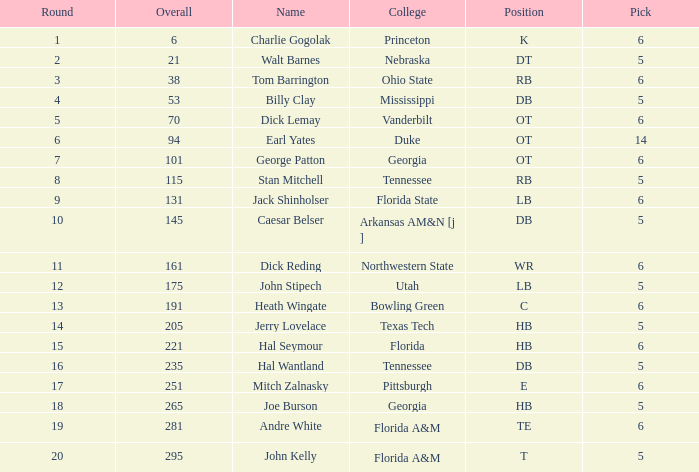What is Name, when Overall is less than 175, and when College is "Georgia"? George Patton. Can you give me this table as a dict? {'header': ['Round', 'Overall', 'Name', 'College', 'Position', 'Pick'], 'rows': [['1', '6', 'Charlie Gogolak', 'Princeton', 'K', '6'], ['2', '21', 'Walt Barnes', 'Nebraska', 'DT', '5'], ['3', '38', 'Tom Barrington', 'Ohio State', 'RB', '6'], ['4', '53', 'Billy Clay', 'Mississippi', 'DB', '5'], ['5', '70', 'Dick Lemay', 'Vanderbilt', 'OT', '6'], ['6', '94', 'Earl Yates', 'Duke', 'OT', '14'], ['7', '101', 'George Patton', 'Georgia', 'OT', '6'], ['8', '115', 'Stan Mitchell', 'Tennessee', 'RB', '5'], ['9', '131', 'Jack Shinholser', 'Florida State', 'LB', '6'], ['10', '145', 'Caesar Belser', 'Arkansas AM&N [j ]', 'DB', '5'], ['11', '161', 'Dick Reding', 'Northwestern State', 'WR', '6'], ['12', '175', 'John Stipech', 'Utah', 'LB', '5'], ['13', '191', 'Heath Wingate', 'Bowling Green', 'C', '6'], ['14', '205', 'Jerry Lovelace', 'Texas Tech', 'HB', '5'], ['15', '221', 'Hal Seymour', 'Florida', 'HB', '6'], ['16', '235', 'Hal Wantland', 'Tennessee', 'DB', '5'], ['17', '251', 'Mitch Zalnasky', 'Pittsburgh', 'E', '6'], ['18', '265', 'Joe Burson', 'Georgia', 'HB', '5'], ['19', '281', 'Andre White', 'Florida A&M', 'TE', '6'], ['20', '295', 'John Kelly', 'Florida A&M', 'T', '5']]} 